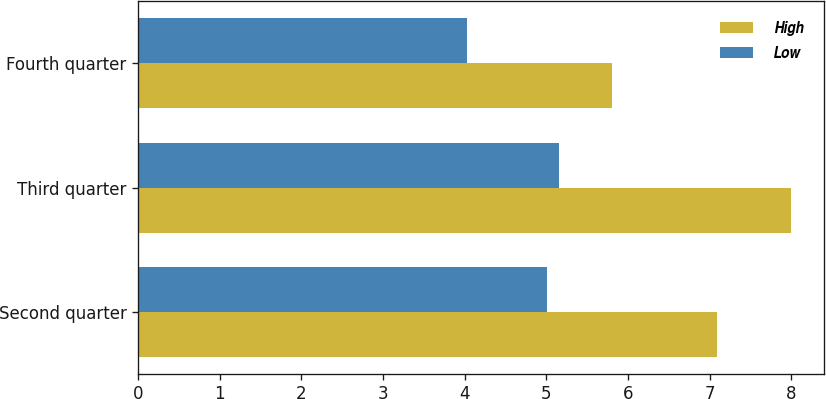Convert chart. <chart><loc_0><loc_0><loc_500><loc_500><stacked_bar_chart><ecel><fcel>Second quarter<fcel>Third quarter<fcel>Fourth quarter<nl><fcel>High<fcel>7.09<fcel>8<fcel>5.8<nl><fcel>Low<fcel>5.01<fcel>5.15<fcel>4.03<nl></chart> 